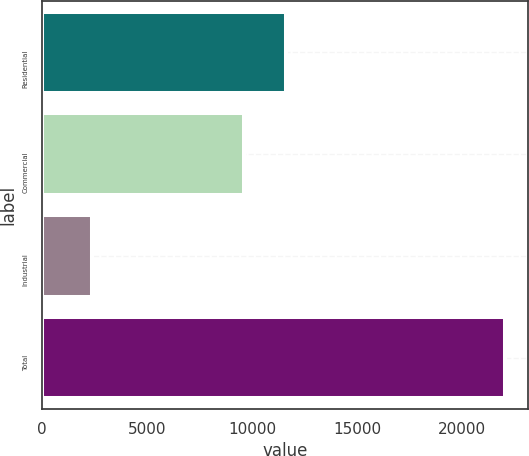<chart> <loc_0><loc_0><loc_500><loc_500><bar_chart><fcel>Residential<fcel>Commercial<fcel>Industrial<fcel>Total<nl><fcel>11609.9<fcel>9643<fcel>2377<fcel>22046<nl></chart> 